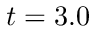<formula> <loc_0><loc_0><loc_500><loc_500>t = 3 . 0</formula> 